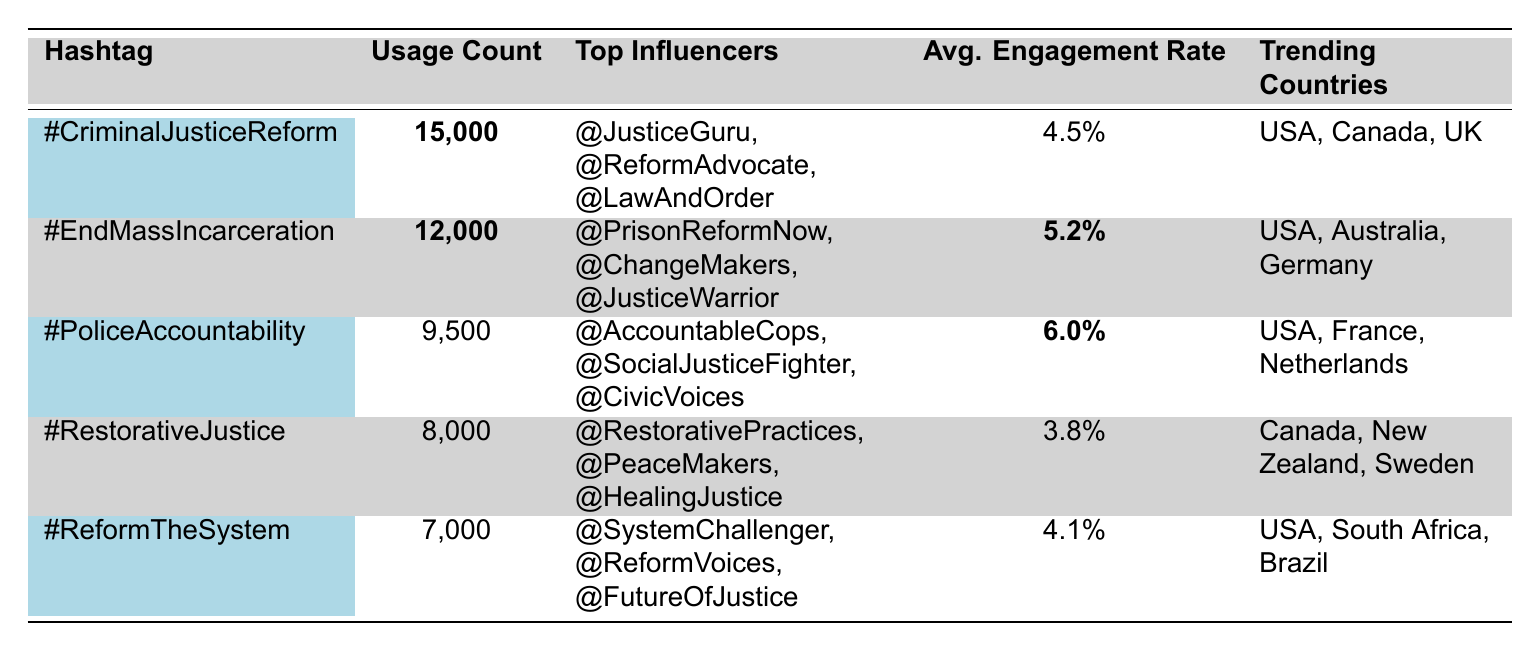What is the usage count of the hashtag #EndMassIncarceration? From the table, the usage count for the hashtag #EndMassIncarceration is clearly stated as 12,000.
Answer: 12,000 Which hashtag has the highest average engagement rate? By examining the average engagement rates listed in the table, #PoliceAccountability has the highest rate at 6.0%.
Answer: #PoliceAccountability What are the top influencers for the hashtag #CriminalJusticeReform? The table shows the top influencers associated with #CriminalJusticeReform are @JusticeGuru, @ReformAdvocate, and @LawAndOrder.
Answer: @JusticeGuru, @ReformAdvocate, @LawAndOrder What is the total usage count of all hashtags listed? To find the total, add each usage count: 15,000 + 12,000 + 9,500 + 8,000 + 7,000 = 51,500.
Answer: 51,500 Is the hashtag #RestorativeJustice more popular than #ReformTheSystem? Comparing usage counts, #RestorativeJustice (8,000) is more popular than #ReformTheSystem (7,000).
Answer: Yes Which engagement rate is the lowest among the hashtags? The average engagement rate for #RestorativeJustice is 3.8%, which is the lowest compared to others.
Answer: 3.8% Are there any hashtags trending in the USA? The table indicates that #CriminalJusticeReform, #EndMassIncarceration, #PoliceAccountability, #ReformTheSystem, and #RestorativeJustice are all trending in the USA.
Answer: Yes What is the difference in usage count between #CriminalJusticeReform and #ReformTheSystem? The usage count for #CriminalJusticeReform is 15,000, and for #ReformTheSystem, it is 7,000. The difference is 15,000 - 7,000 = 8,000.
Answer: 8,000 List all the countries trending with the hashtag #PoliceAccountability. The countries trending with #PoliceAccountability are USA, France, and Netherlands as per the table.
Answer: USA, France, Netherlands Which hashtag has the least usage count? The hashtag with the least usage count is #ReformTheSystem with 7,000.
Answer: #ReformTheSystem 